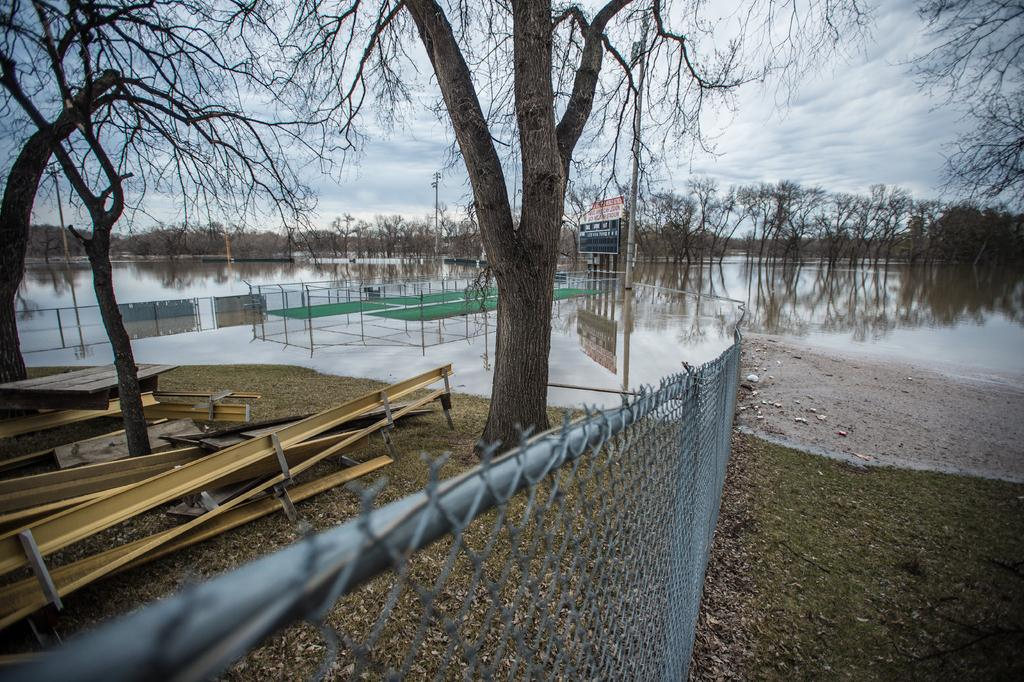What type of vegetation can be seen in the image? There is grass in the image. What type of structures are present in the image? There are fences, metal objects, poles, and boards in the image. What natural elements can be seen in the image? There are trees and water visible in the image. What is visible in the background of the image? The sky is visible in the background of the image, with clouds present. Can you describe the unspecified objects in the image? Unfortunately, the facts do not provide enough information to describe the unspecified objects in the image. Can you tell me how many airports are visible in the image? There are no airports present in the image. Are there any snakes visible in the image? There is no mention of snakes in the provided facts, and therefore we cannot determine if any are present in the image. 